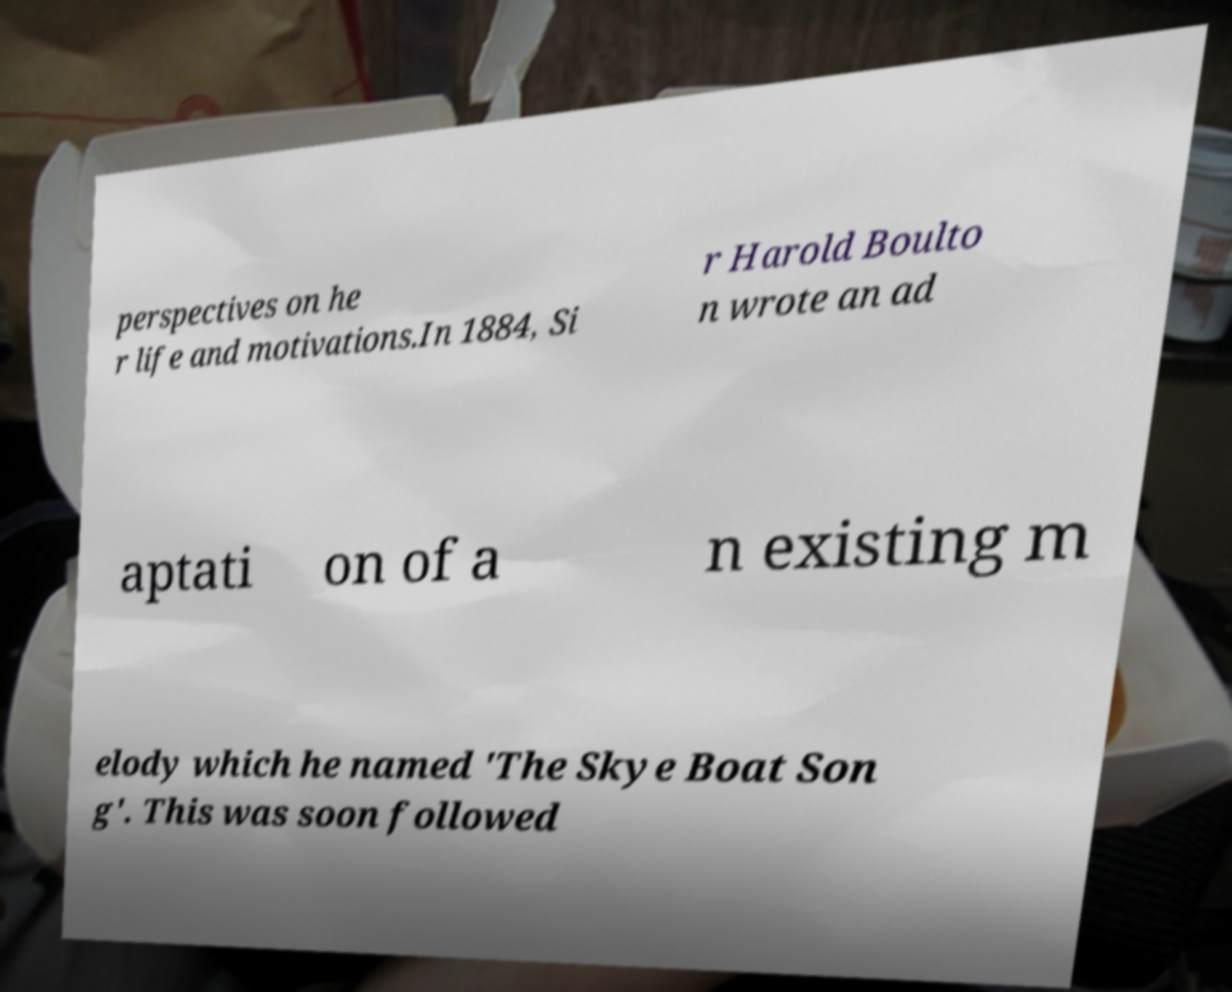I need the written content from this picture converted into text. Can you do that? perspectives on he r life and motivations.In 1884, Si r Harold Boulto n wrote an ad aptati on of a n existing m elody which he named 'The Skye Boat Son g'. This was soon followed 